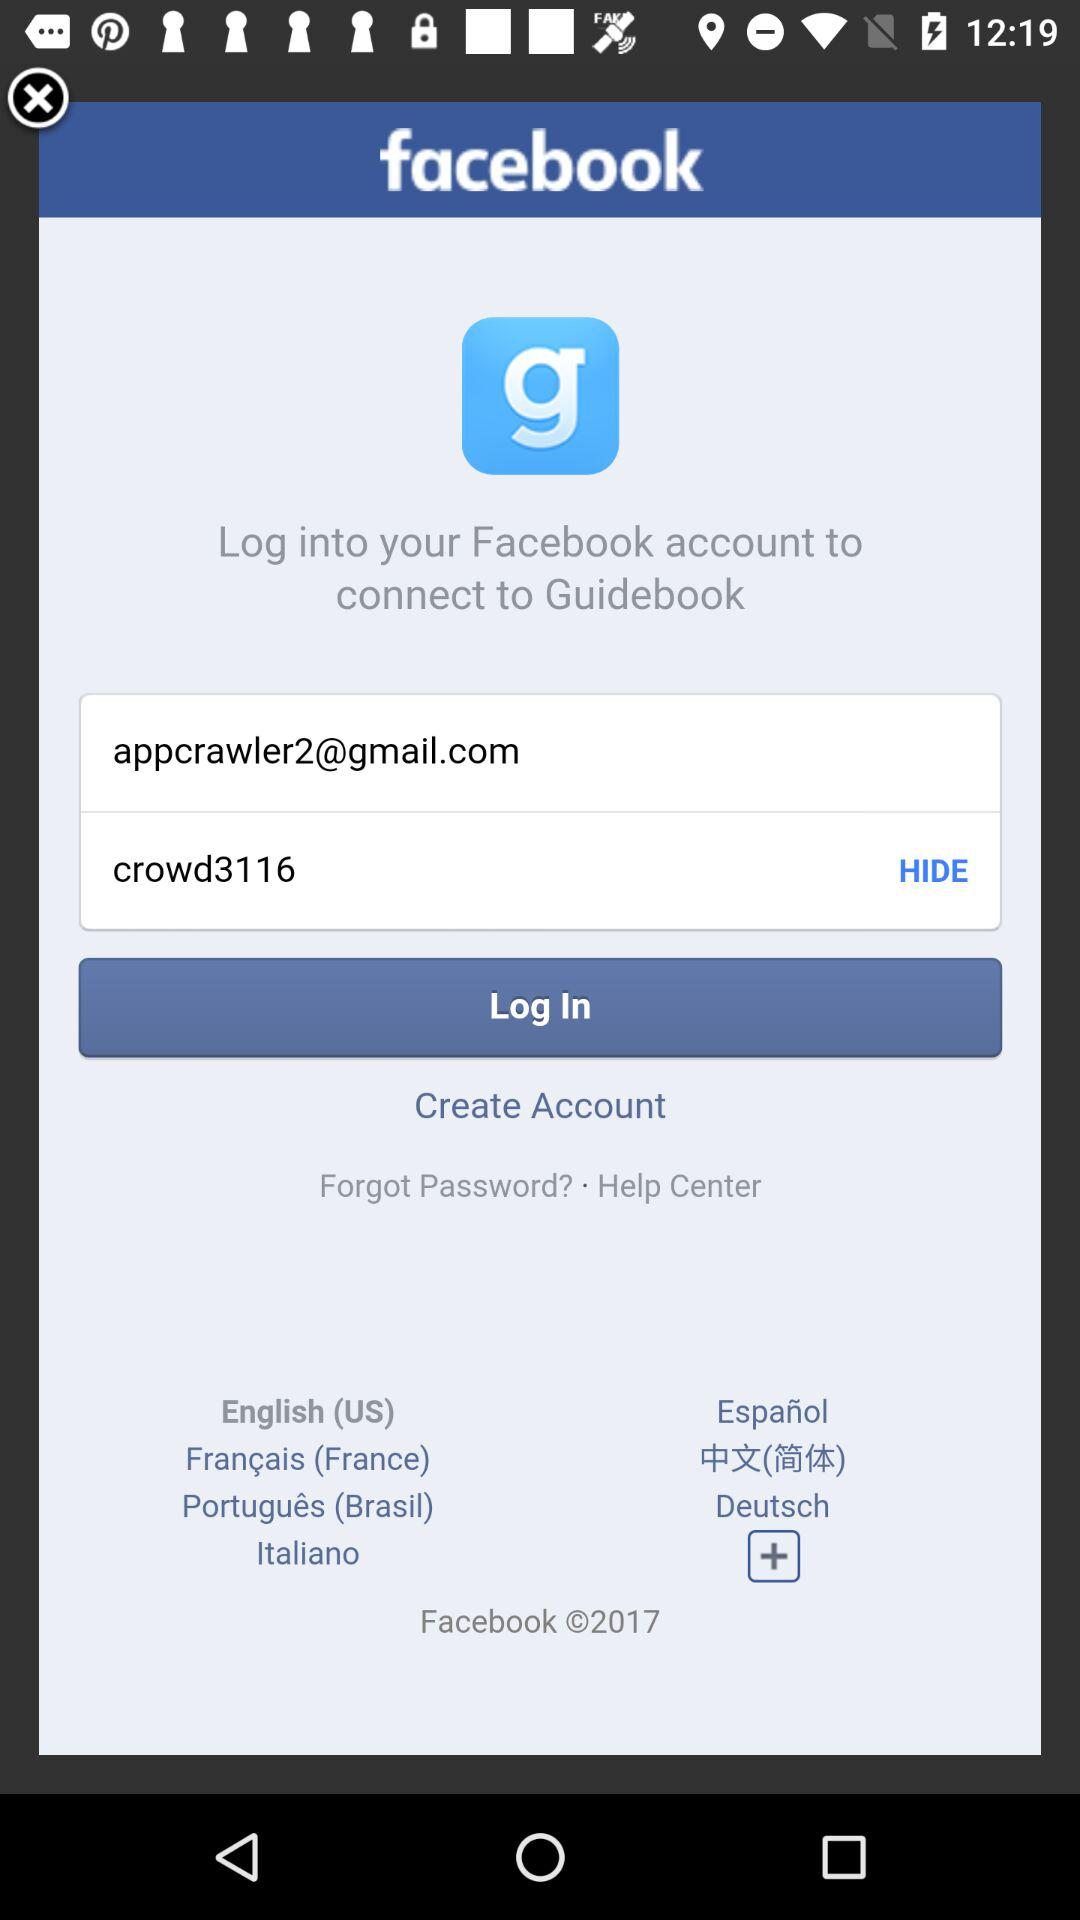How many text inputs are there with text values?
Answer the question using a single word or phrase. 2 